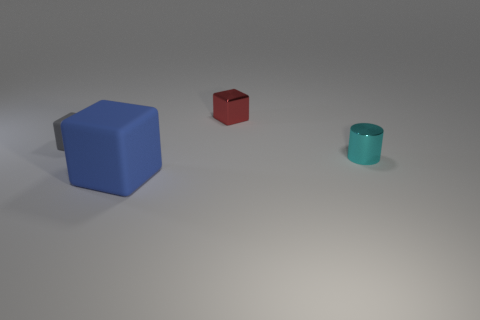Add 4 red metal things. How many objects exist? 8 Subtract all blocks. How many objects are left? 1 Subtract 0 gray cylinders. How many objects are left? 4 Subtract all gray matte cubes. Subtract all small cylinders. How many objects are left? 2 Add 2 small cylinders. How many small cylinders are left? 3 Add 4 tiny metal things. How many tiny metal things exist? 6 